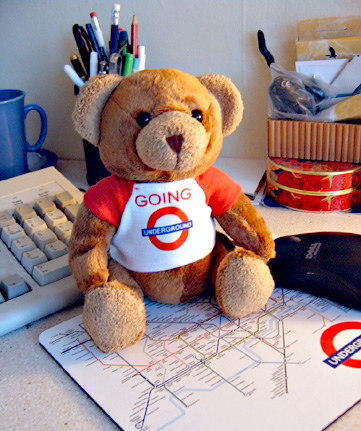Please transcribe the text in this image. GOING 